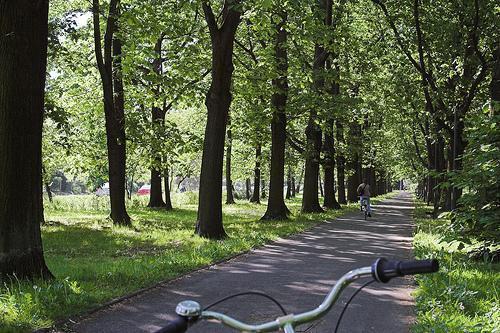How many bikes are there?
Give a very brief answer. 1. 